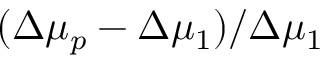<formula> <loc_0><loc_0><loc_500><loc_500>( \Delta \mu _ { p } - \Delta \mu _ { 1 } ) / \Delta \mu _ { 1 }</formula> 